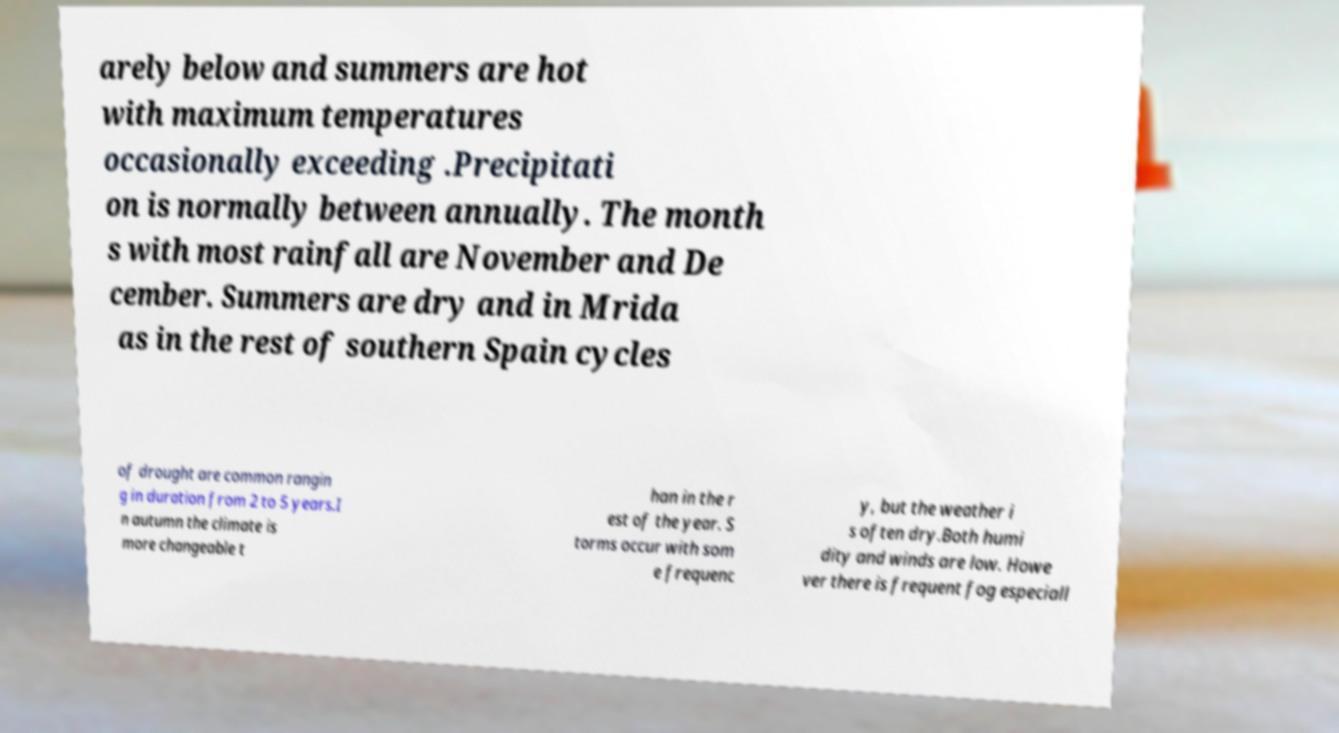Could you extract and type out the text from this image? arely below and summers are hot with maximum temperatures occasionally exceeding .Precipitati on is normally between annually. The month s with most rainfall are November and De cember. Summers are dry and in Mrida as in the rest of southern Spain cycles of drought are common rangin g in duration from 2 to 5 years.I n autumn the climate is more changeable t han in the r est of the year. S torms occur with som e frequenc y, but the weather i s often dry.Both humi dity and winds are low. Howe ver there is frequent fog especiall 